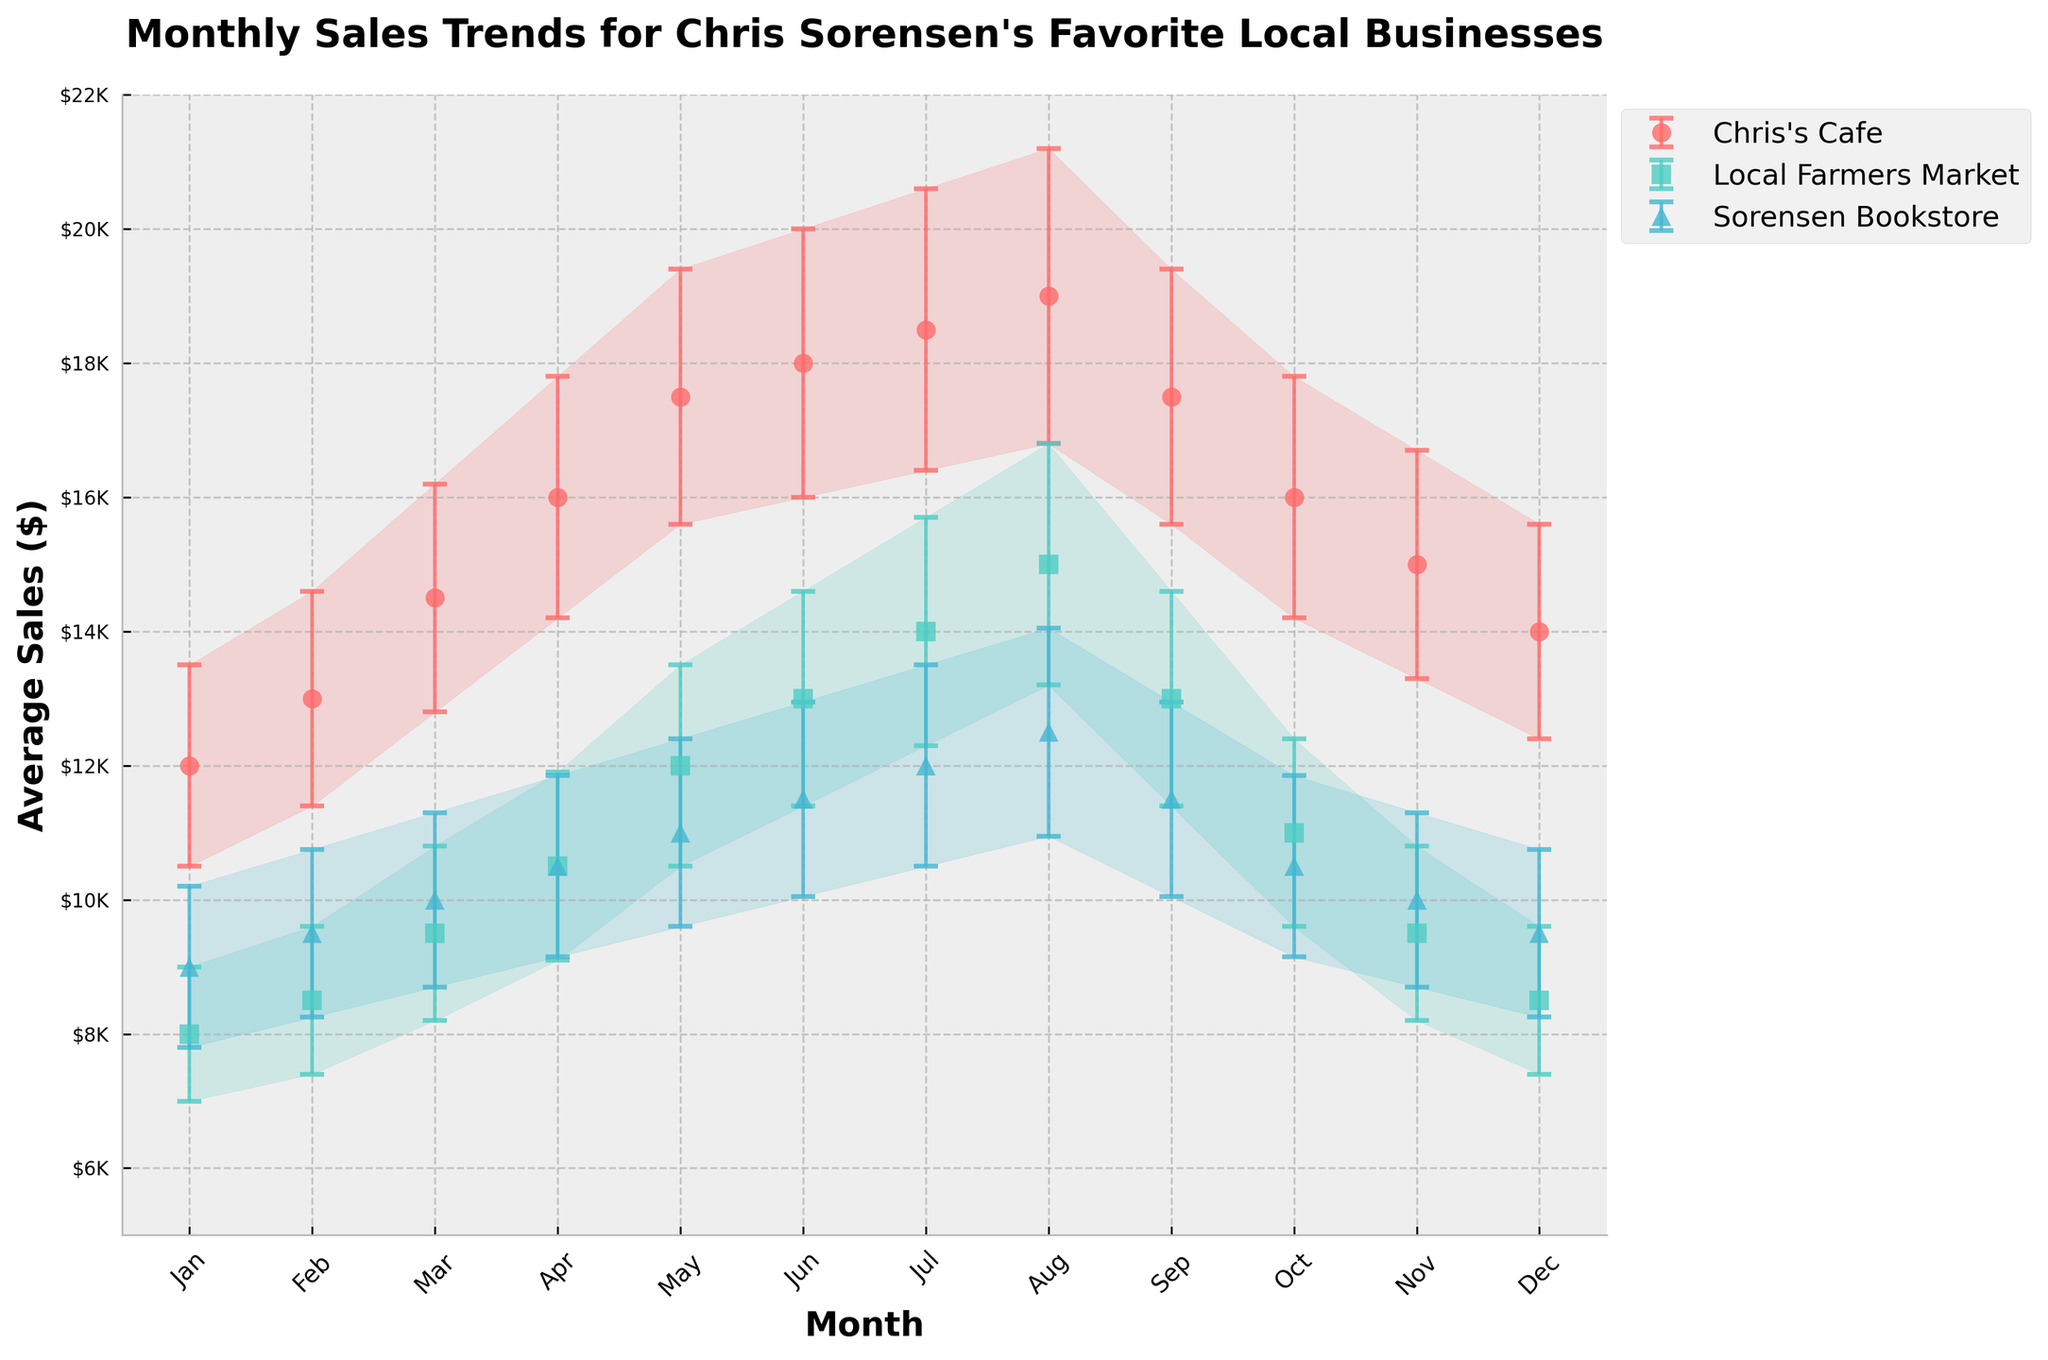When do Chris's Cafe's sales peak? Look for the highest point on the line representing Chris's Cafe. The peak occurs in August.
Answer: August How does the trend of Sorensen Bookstore's sales compare between January and December? Compare the endpoints of the Sorensen Bookstore line. Sales start at $9,000 in January and end at $9,500 in December.
Answer: Increase slightly Which business has the highest standard deviation in July? Find the error bars for each business in July and identify the largest. Chris's Cafe has the highest standard deviation of 2,100.
Answer: Chris's Cafe What is the average sales difference between the highest and lowest months for the Local Farmers Market? Identify the highest (August at $15,000) and lowest (January at $8,000) sales months. Subtract the lowest from the highest: $15,000 - $8,000 = $7,000.
Answer: $7,000 Which month has the smallest sales deviation for all businesses? Compare the lengths of error bars across all months. January shows the smallest, especially for Chris's Cafe (1,500), Local Farmers Market (1,000), Sorensen Bookstore (1,200).
Answer: January During which months do all three businesses show increasing sales trends? Trace each business line through the months. All businesses show increasing trends from January to June.
Answer: January to June How does Chris's Cafe's sales in March compare to those in November? Compare the sales values of Chris's Cafe in March ($14,500) and November ($15,000).
Answer: March is lower Which business exhibits the most consistent sales throughout the year? Consistency is shown by short error bars and minimal variation in the line. Sorensen Bookstore shows the least fluctuation.
Answer: Sorensen Bookstore What are the sales values and standard deviations for all three businesses in April? Read the plot for April's values and corresponding error bars: Chris's Cafe ($16,000, $1,800), Local Farmers Market ($10,500, $1,400), Sorensen Bookstore ($10,500, $1,350).
Answer: Chris's Cafe: $16,000 & $1,800, Local Farmers Market: $10,500 & $1,400, Sorensen Bookstore: $10,500 & $1,350 